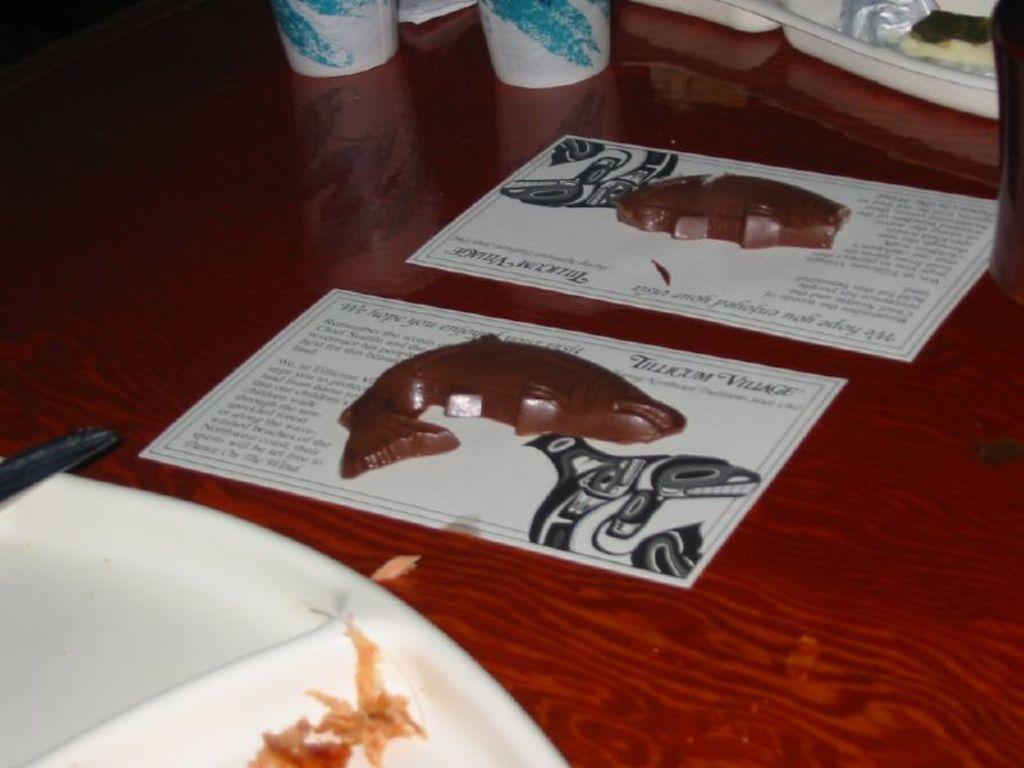Describe this image in one or two sentences. In this image I can see a table , on the table I can see a plate ,paper,glass kept on it 